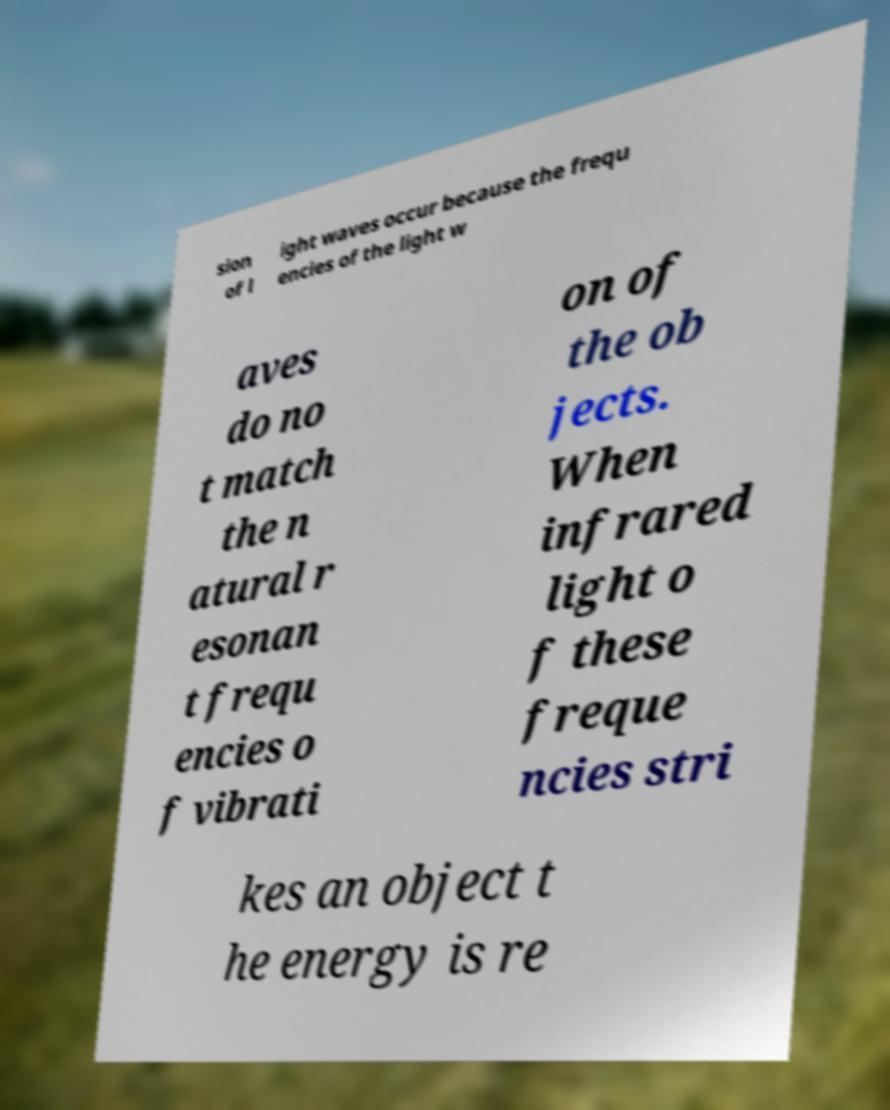Please read and relay the text visible in this image. What does it say? sion of l ight waves occur because the frequ encies of the light w aves do no t match the n atural r esonan t frequ encies o f vibrati on of the ob jects. When infrared light o f these freque ncies stri kes an object t he energy is re 